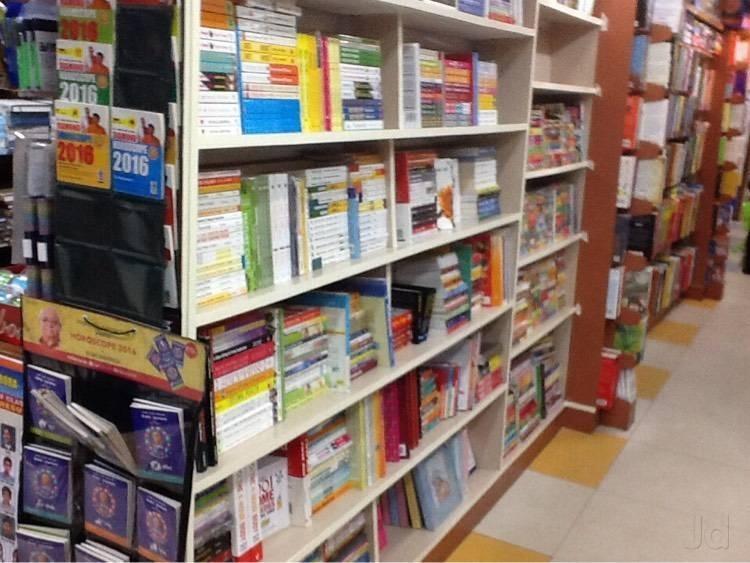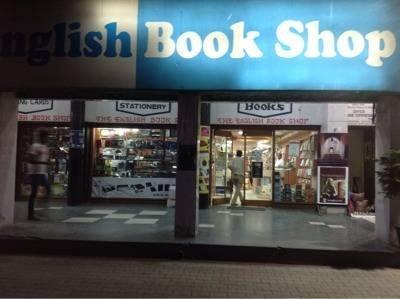The first image is the image on the left, the second image is the image on the right. For the images displayed, is the sentence "One image is taken from outside the shop." factually correct? Answer yes or no. Yes. The first image is the image on the left, the second image is the image on the right. Considering the images on both sides, is "The exterior of a bookshop with plate glass windows is seen in one image, while a second image shows interior racks of books." valid? Answer yes or no. Yes. 